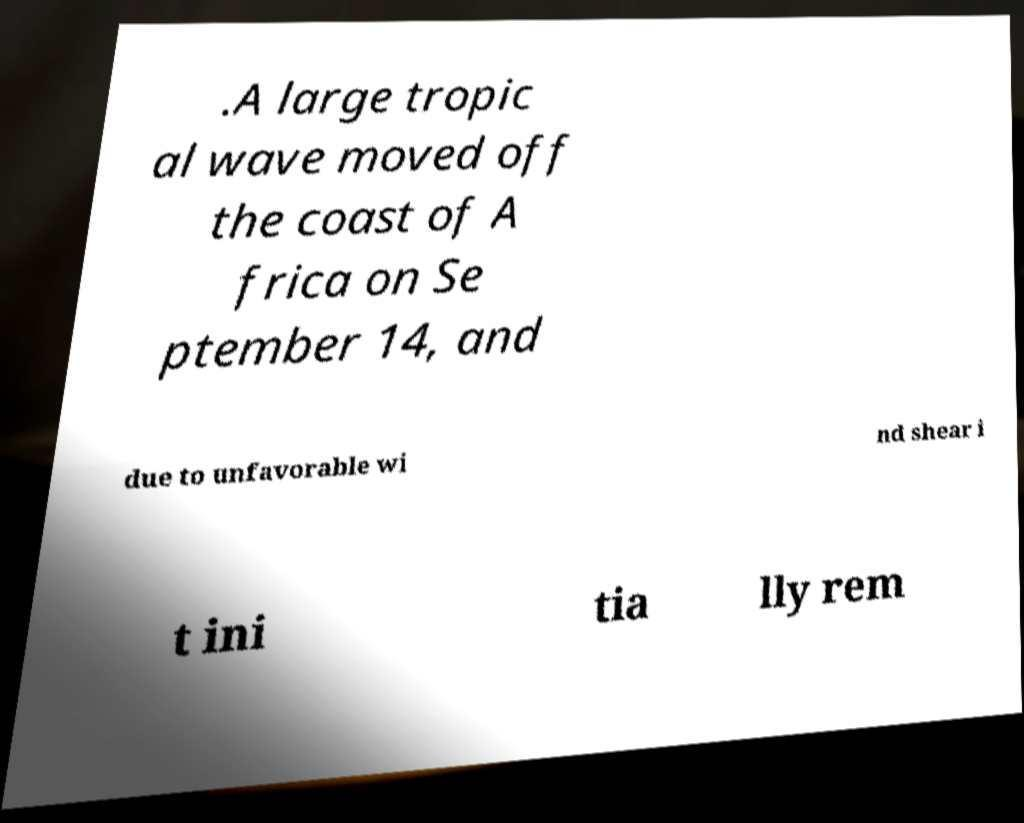Could you assist in decoding the text presented in this image and type it out clearly? .A large tropic al wave moved off the coast of A frica on Se ptember 14, and due to unfavorable wi nd shear i t ini tia lly rem 